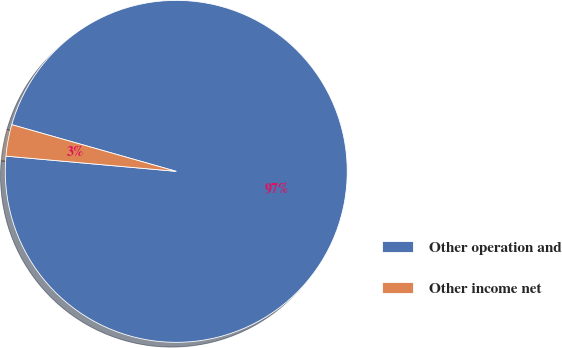Convert chart. <chart><loc_0><loc_0><loc_500><loc_500><pie_chart><fcel>Other operation and<fcel>Other income net<nl><fcel>97.02%<fcel>2.98%<nl></chart> 